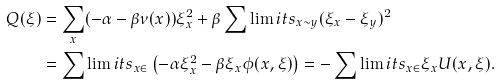Convert formula to latex. <formula><loc_0><loc_0><loc_500><loc_500>Q ( \xi ) & = \sum _ { x } ( - \alpha - \beta \nu ( x ) ) \xi ^ { 2 } _ { x } + \beta \sum \lim i t s _ { x \sim y } ( \xi _ { x } - \xi _ { y } ) ^ { 2 } \\ & = \sum \lim i t s _ { x \in \L } \left ( - \alpha \xi _ { x } ^ { 2 } - \beta \xi _ { x } \phi ( x , \xi ) \right ) = - \sum \lim i t s _ { x \in \L } \xi _ { x } U ( x , \xi ) .</formula> 